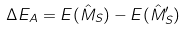<formula> <loc_0><loc_0><loc_500><loc_500>\Delta E _ { A } = E ( \hat { M } _ { S } ) - E ( \hat { M } _ { S } ^ { \prime } )</formula> 